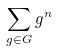<formula> <loc_0><loc_0><loc_500><loc_500>\sum _ { g \in G } g ^ { n }</formula> 